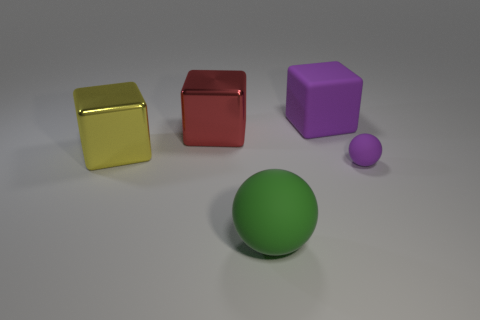If I were to remove one object, which one would least affect the balance of the composition? If balance is the main concern, removing the smaller purple sphere would likely have the least impact on the overall composition. Its size and color are already present in the larger purple cube, and its position at the far right makes it less central to the balance of the arrangement. 